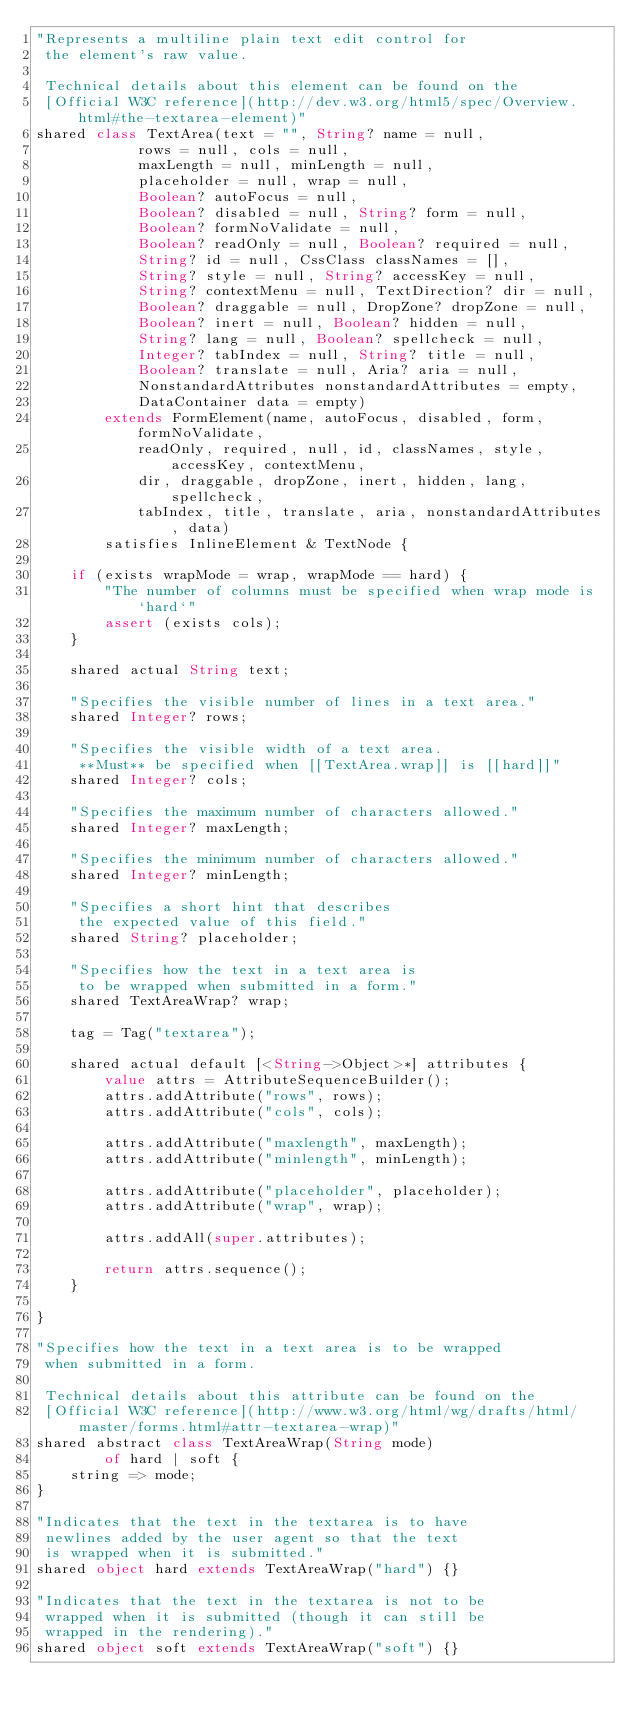Convert code to text. <code><loc_0><loc_0><loc_500><loc_500><_Ceylon_>"Represents a multiline plain text edit control for
 the element's raw value.
 
 Technical details about this element can be found on the
 [Official W3C reference](http://dev.w3.org/html5/spec/Overview.html#the-textarea-element)"
shared class TextArea(text = "", String? name = null,
            rows = null, cols = null, 
            maxLength = null, minLength = null,
            placeholder = null, wrap = null,
            Boolean? autoFocus = null,
            Boolean? disabled = null, String? form = null,
            Boolean? formNoValidate = null,
            Boolean? readOnly = null, Boolean? required = null,
            String? id = null, CssClass classNames = [],
            String? style = null, String? accessKey = null,
            String? contextMenu = null, TextDirection? dir = null,
            Boolean? draggable = null, DropZone? dropZone = null,
            Boolean? inert = null, Boolean? hidden = null,
            String? lang = null, Boolean? spellcheck = null,
            Integer? tabIndex = null, String? title = null,
            Boolean? translate = null, Aria? aria = null,
            NonstandardAttributes nonstandardAttributes = empty,
            DataContainer data = empty)
        extends FormElement(name, autoFocus, disabled, form, formNoValidate,
            readOnly, required, null, id, classNames, style, accessKey, contextMenu,
            dir, draggable, dropZone, inert, hidden, lang, spellcheck,
            tabIndex, title, translate, aria, nonstandardAttributes, data)
        satisfies InlineElement & TextNode {
    
    if (exists wrapMode = wrap, wrapMode == hard) {
        "The number of columns must be specified when wrap mode is `hard`"
        assert (exists cols);
    }

    shared actual String text;

    "Specifies the visible number of lines in a text area."
    shared Integer? rows;

    "Specifies the visible width of a text area.
     **Must** be specified when [[TextArea.wrap]] is [[hard]]"
    shared Integer? cols;

    "Specifies the maximum number of characters allowed."
    shared Integer? maxLength;

    "Specifies the minimum number of characters allowed."
    shared Integer? minLength;

    "Specifies a short hint that describes
     the expected value of this field."
    shared String? placeholder;

    "Specifies how the text in a text area is
     to be wrapped when submitted in a form."
    shared TextAreaWrap? wrap;

    tag = Tag("textarea");
    
    shared actual default [<String->Object>*] attributes {
        value attrs = AttributeSequenceBuilder();
        attrs.addAttribute("rows", rows);
        attrs.addAttribute("cols", cols);

        attrs.addAttribute("maxlength", maxLength);
        attrs.addAttribute("minlength", minLength);

        attrs.addAttribute("placeholder", placeholder);
        attrs.addAttribute("wrap", wrap);
        
        attrs.addAll(super.attributes);

        return attrs.sequence();
    }

}

"Specifies how the text in a text area is to be wrapped
 when submitted in a form.

 Technical details about this attribute can be found on the
 [Official W3C reference](http://www.w3.org/html/wg/drafts/html/master/forms.html#attr-textarea-wrap)"
shared abstract class TextAreaWrap(String mode)
        of hard | soft {
    string => mode;
}

"Indicates that the text in the textarea is to have
 newlines added by the user agent so that the text
 is wrapped when it is submitted."
shared object hard extends TextAreaWrap("hard") {}

"Indicates that the text in the textarea is not to be
 wrapped when it is submitted (though it can still be
 wrapped in the rendering)."
shared object soft extends TextAreaWrap("soft") {}
</code> 